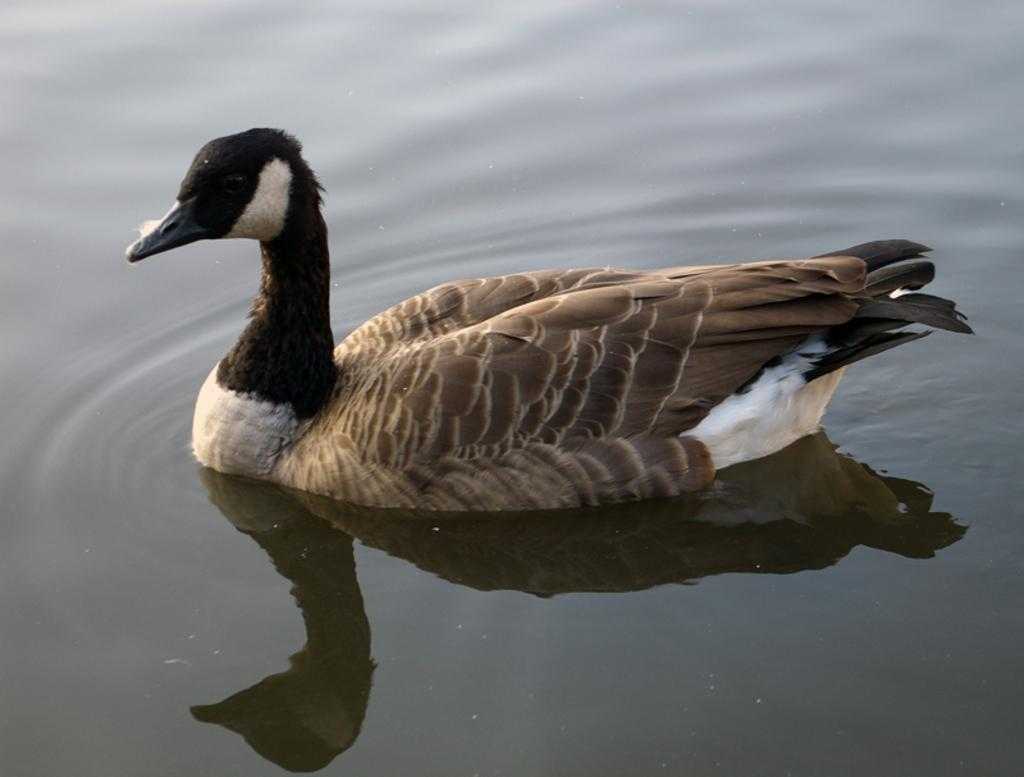What animal is present in the picture? There is a duck in the picture. What is the duck doing in the picture? The duck is swimming in the water. What color are the duck's feathers? The duck has brown feathers. What type of team is visible in the picture? There is no team present in the image; it features a duck swimming in the water. What event is taking place in the picture? There is no specific event depicted in the image; it simply shows a duck swimming in the water. 